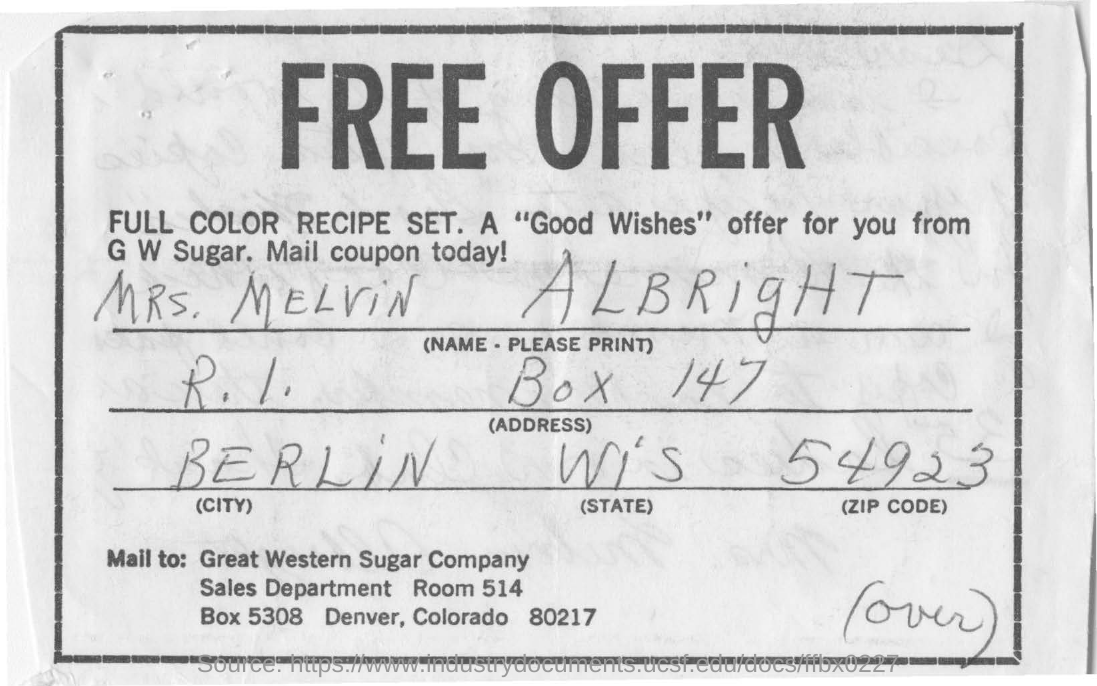List a handful of essential elements in this visual. What zip code number was given? It was 54923... The document contains the name of a person who is referred to as "MRS. MELVIN ALBRIGHT. Mrs. Melvin Albright belongs to the city of Berlin. 